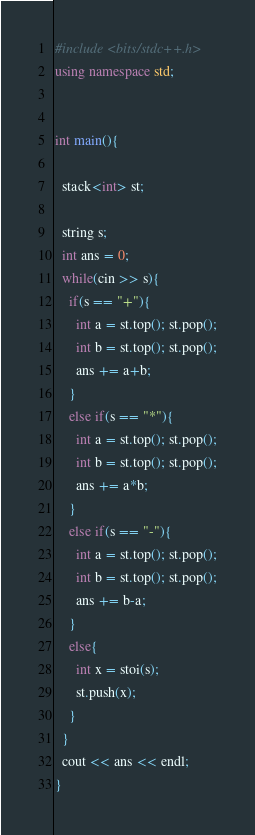Convert code to text. <code><loc_0><loc_0><loc_500><loc_500><_C++_>#include <bits/stdc++.h>
using namespace std;


int main(){

  stack<int> st;

  string s;
  int ans = 0;
  while(cin >> s){
    if(s == "+"){
      int a = st.top(); st.pop();
      int b = st.top(); st.pop();
      ans += a+b;
    }
    else if(s == "*"){
      int a = st.top(); st.pop();
      int b = st.top(); st.pop();
      ans += a*b;
    }
    else if(s == "-"){
      int a = st.top(); st.pop();
      int b = st.top(); st.pop();
      ans += b-a;
    }
    else{
      int x = stoi(s);
      st.push(x);
    }
  }
  cout << ans << endl;
}</code> 